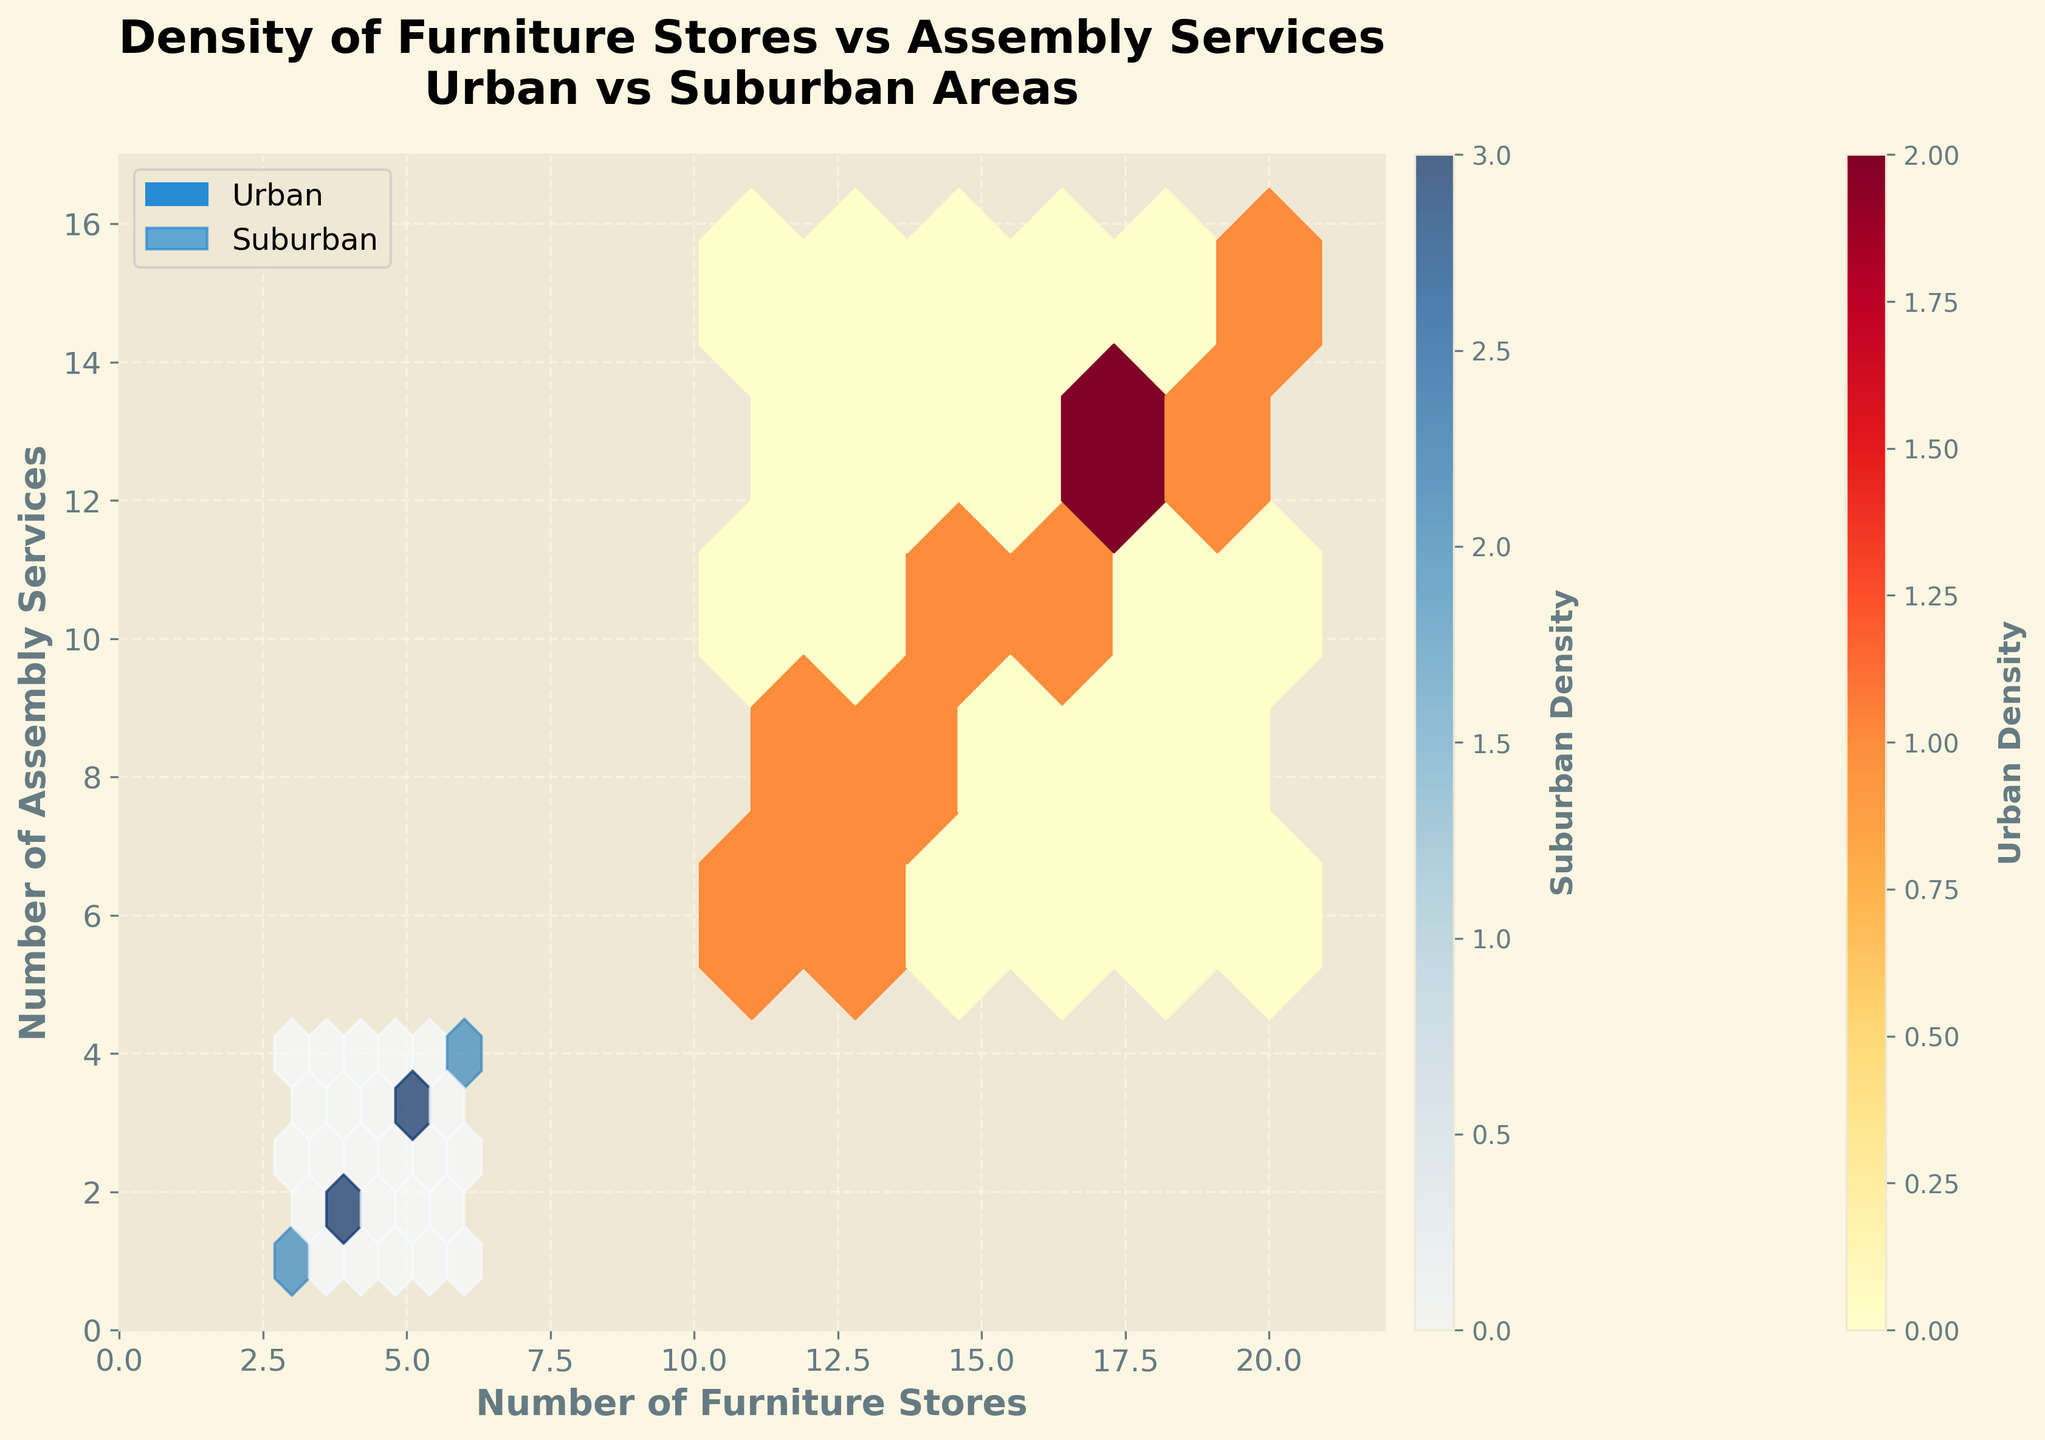What does the title of the figure say? The title is prominently displayed at the top of the figure and reads "Density of Furniture Stores vs Assembly Services\nUrban vs Suburban Areas."
Answer: Density of Furniture Stores vs Assembly Services in Urban vs Suburban Areas What are the labels on the x and y axes? The labels on the x and y axes are clearly marked with "Number of Furniture Stores" (x-axis) and "Number of Assembly Services" (y-axis) respectively.
Answer: Number of Furniture Stores and Number of Assembly Services Which color represents urban areas, and which color represents suburban areas? Urban areas are represented by shades of red, while suburban areas are represented by shades of blue, as indicated in the legend.
Answer: Urban: red, Suburban: blue Where is the highest density of furniture stores and assembly services for urban areas concentrated? The highest density for urban areas is concentrated around the region where furniture stores and assembly services are both in high numbers. This is shown by the darker red hexagons in the upper right part of the plot.
Answer: Upper right part Which area type has a higher average density of furniture stores and assembly services? To determine the average density, observe the color intensity and distribution of hexagons. Urban areas (red) show greater density and intensity, indicated by more and darker hexagons as compared to suburban areas (blue).
Answer: Urban Comparing the urban and suburban data, which has the higher maximum number of furniture stores? By examining the x-axis and observing the hexagons, the urban areas reach a maximum of 20 furniture stores while suburban areas do not exceed 6.
Answer: Urban How does the density of suburban areas' assembly services compare to that of urban areas? The density of suburban assembly services is considerably lower, as evidenced by lighter blue hexagons compared to the denser and darker red hexagons for urban assembly services.
Answer: Lower What can be inferred about the relationship between furniture stores and assembly services in urban areas compared to suburban areas? Urban areas show a stronger and denser relationship between furniture stores and assembly services, with higher counts and darker hexagons, implying more concentration in urban areas.
Answer: Stronger in urban areas Are there any suburban areas with a high density of both furniture stores and assembly services? The plot shows relatively light blue hexagons spread out, indicating that suburban areas do not have a high density of both furniture stores and assembly services.
Answer: No 